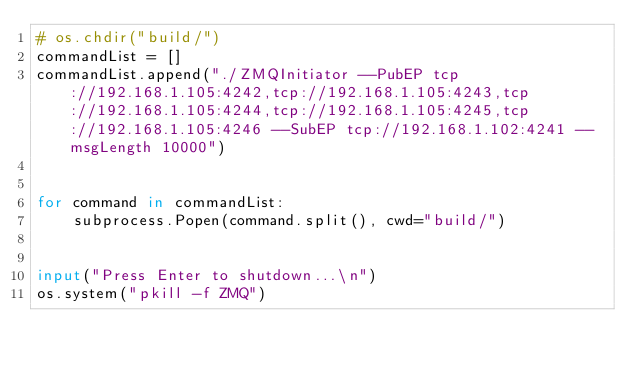<code> <loc_0><loc_0><loc_500><loc_500><_Python_># os.chdir("build/")
commandList = []
commandList.append("./ZMQInitiator --PubEP tcp://192.168.1.105:4242,tcp://192.168.1.105:4243,tcp://192.168.1.105:4244,tcp://192.168.1.105:4245,tcp://192.168.1.105:4246 --SubEP tcp://192.168.1.102:4241 --msgLength 10000")


for command in commandList:
    subprocess.Popen(command.split(), cwd="build/")


input("Press Enter to shutdown...\n")
os.system("pkill -f ZMQ")
</code> 